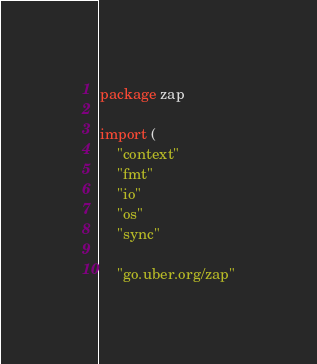<code> <loc_0><loc_0><loc_500><loc_500><_Go_>package zap

import (
	"context"
	"fmt"
	"io"
	"os"
	"sync"

	"go.uber.org/zap"</code> 